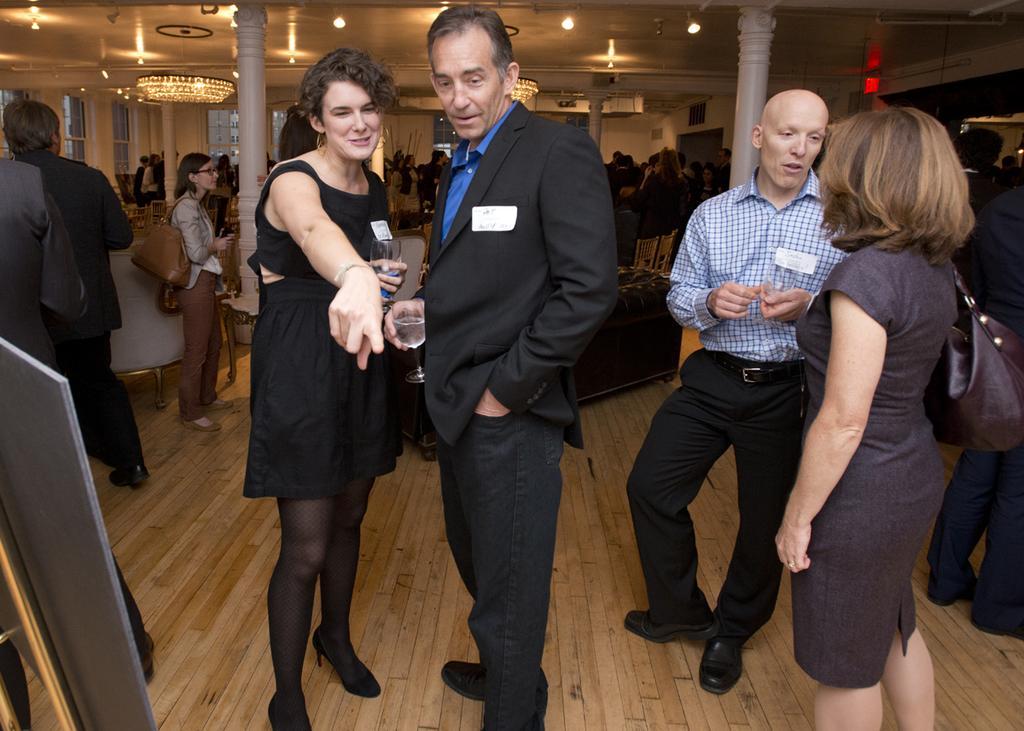Can you describe this image briefly? In this image I can see number of people are standing. I can also see few of them are holding glasses and few of them are carrying bags. In the background I can see number of lights on the ceiling and on the left side of the image I can see a board. I can also see few pillars in the background. 